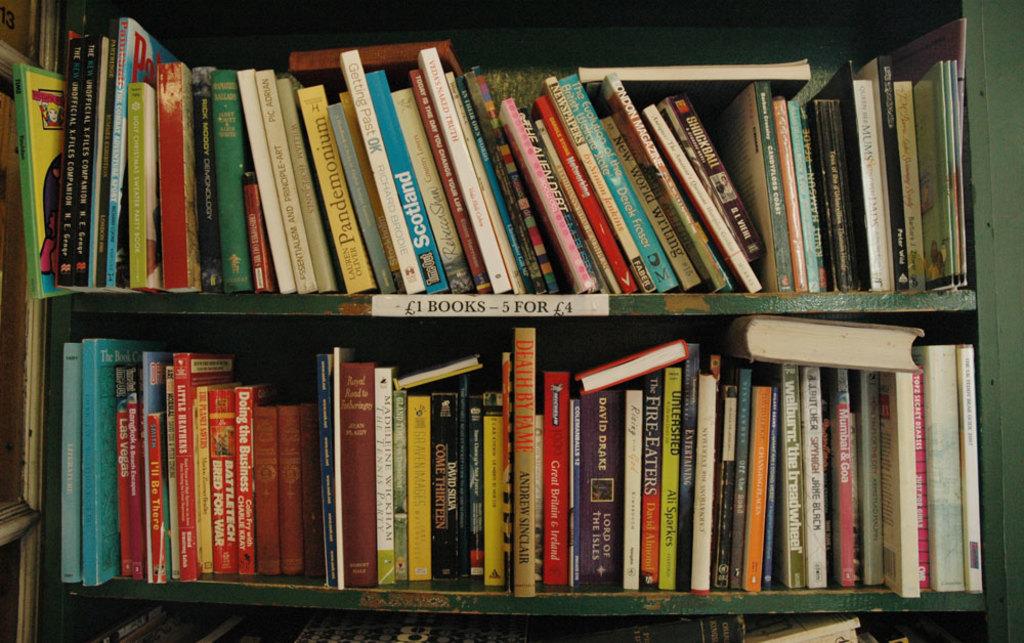How much are the books?
Offer a terse response. 1 or 5 for 4. What is the title of the black and red book on bottom shelf?
Make the answer very short. Unanswerable. 